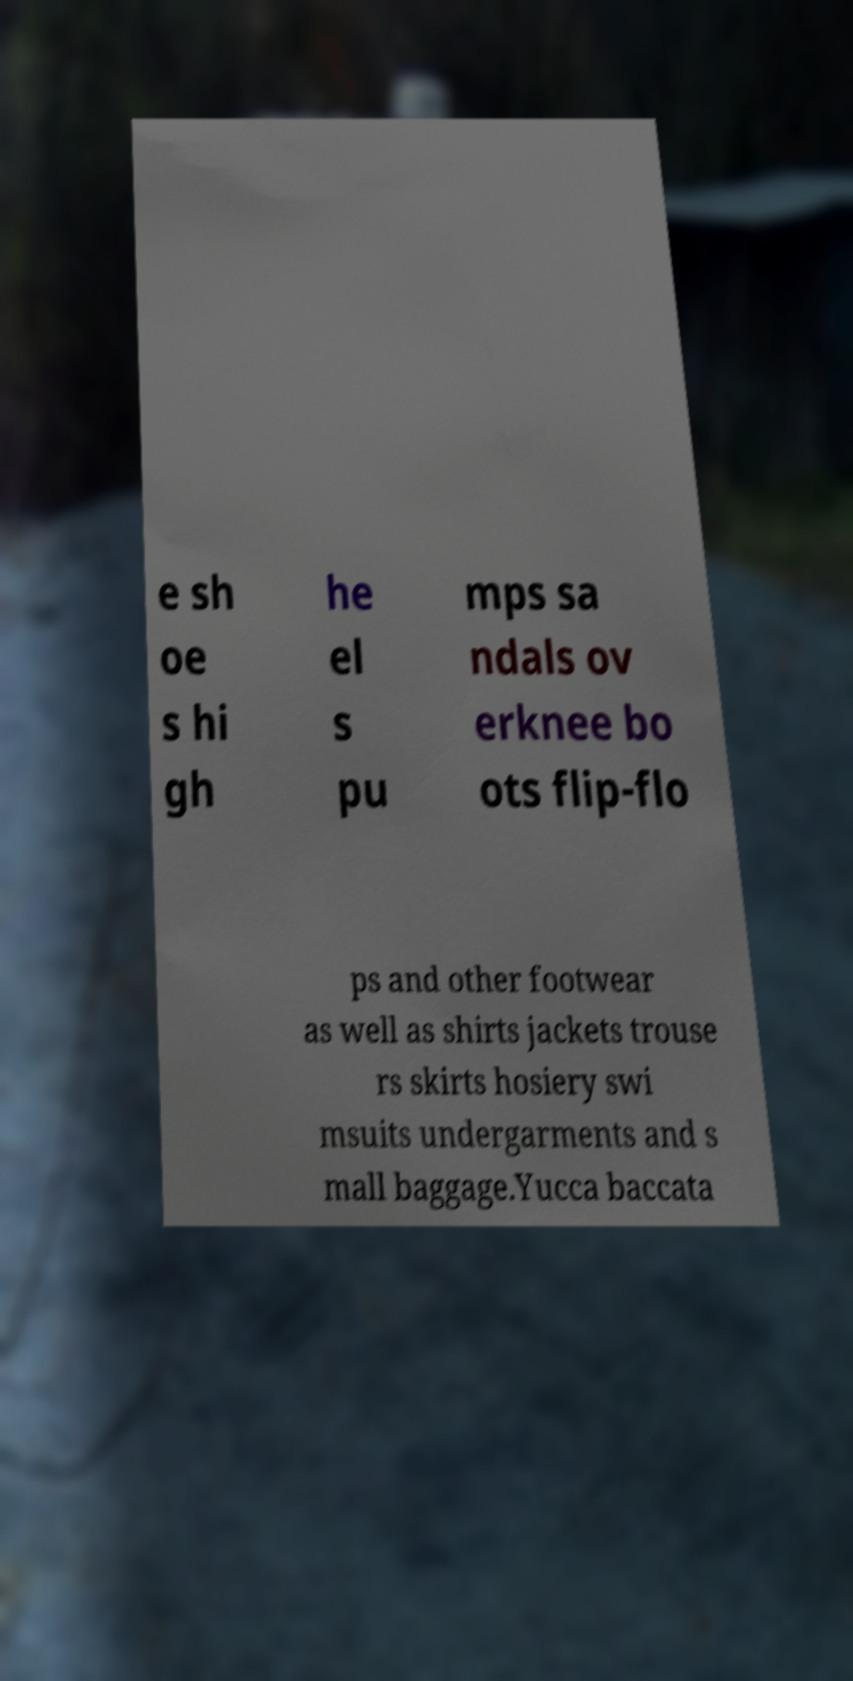Can you read and provide the text displayed in the image?This photo seems to have some interesting text. Can you extract and type it out for me? e sh oe s hi gh he el s pu mps sa ndals ov erknee bo ots flip-flo ps and other footwear as well as shirts jackets trouse rs skirts hosiery swi msuits undergarments and s mall baggage.Yucca baccata 